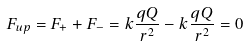<formula> <loc_0><loc_0><loc_500><loc_500>F _ { u p } = F _ { + } + F _ { - } = k \frac { q Q } { r ^ { 2 } } - k \frac { q Q } { r ^ { 2 } } = 0</formula> 